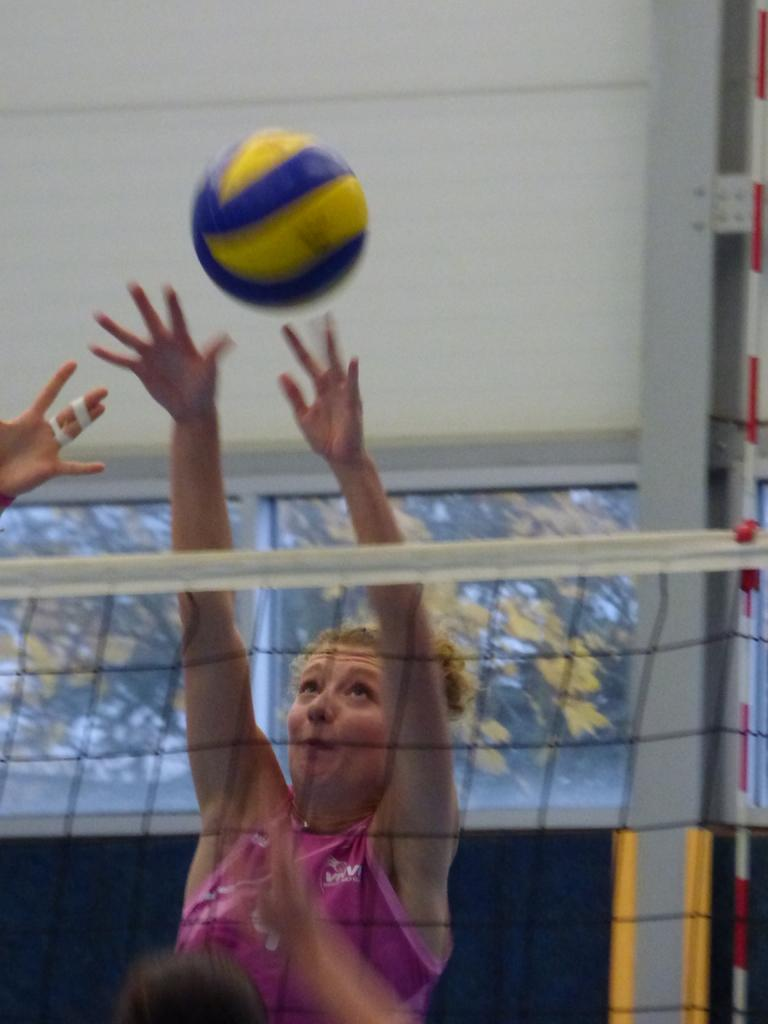Who is the main subject in the image? There is a girl in the image. What is the girl wearing? The girl is wearing a pink t-shirt. What activity is the girl engaged in? The girl is playing volleyball. What can be seen in the background of the image? There is a fencing net, a glass window, and a white wall in the image. How many rings can be seen on the girl's fingers in the image? There are no rings visible on the girl's fingers in the image. What is the girl's digestive system like in the image? The image does not provide any information about the girl's digestive system. Is there a car visible in the image? No, there is no car present in the image. 